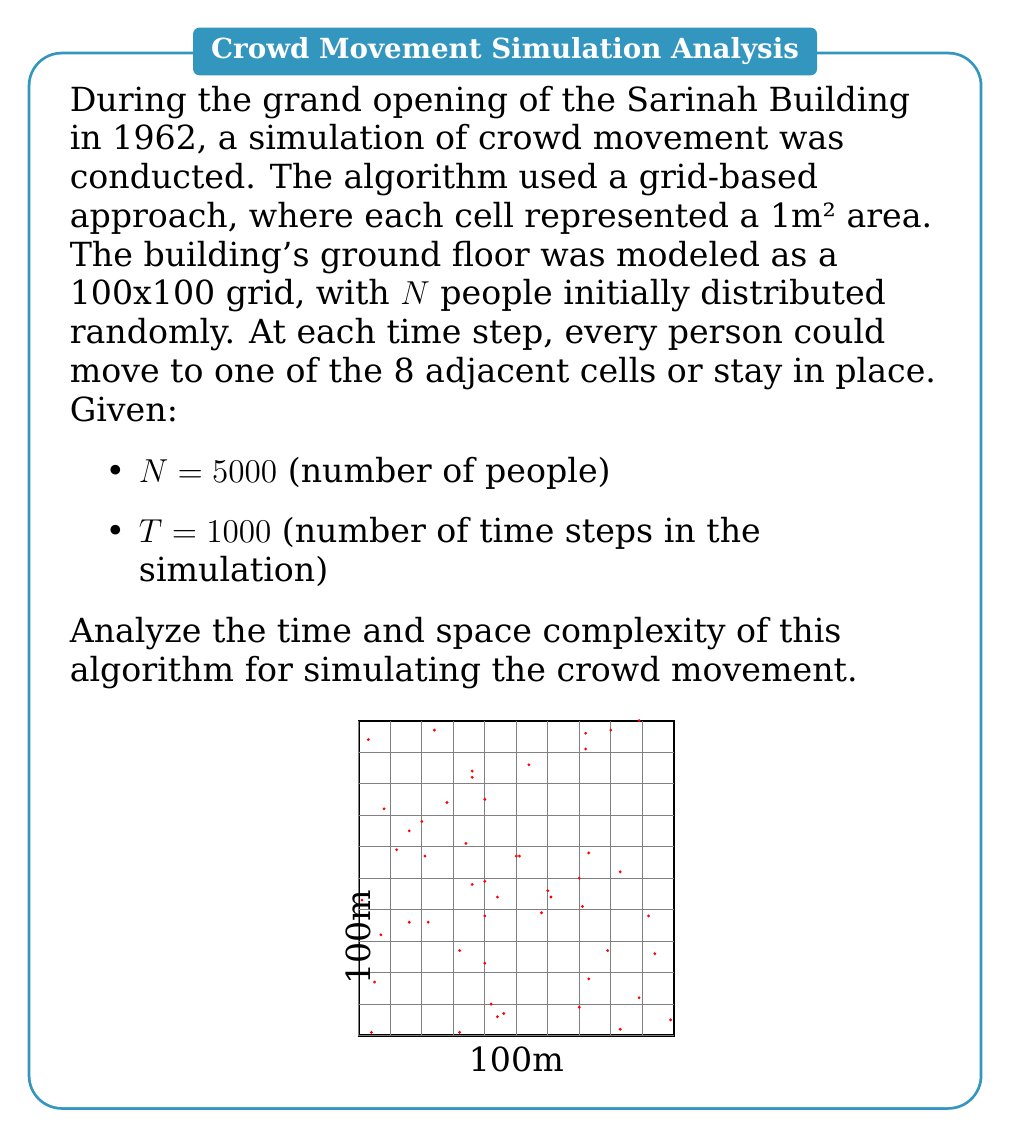Provide a solution to this math problem. Let's analyze the time and space complexity step by step:

1. Initialization:
   - Creating a 100x100 grid: $O(1)$ time and $O(10000) = O(1)$ space (constant)
   - Placing N people randomly: $O(N)$ time and $O(N)$ space

2. Simulation loop:
   - Outer loop runs for T time steps: $O(T)$
   - Inner loop processes N people: $O(N)$
   - For each person:
     a. Check 8 adjacent cells: $O(1)$
     b. Choose a valid move: $O(1)$
     c. Update position: $O(1)$

3. Time complexity analysis:
   - Total time complexity: $O(N + T \cdot N \cdot 1) = O(TN)$

4. Space complexity analysis:
   - Grid representation: $O(1)$ (constant 100x100)
   - People's positions: $O(N)$
   - No additional data structures needed

5. Substituting the given values:
   - Time complexity: $O(TN) = O(1000 \cdot 5000) = O(5,000,000)$
   - Space complexity: $O(N) = O(5000)$

The algorithm's efficiency could be improved by using more sophisticated data structures or parallel processing techniques, but this basic implementation provides a straightforward simulation of crowd movement during the Sarinah Building's grand opening.
Answer: Time complexity: $O(TN)$, Space complexity: $O(N)$ 